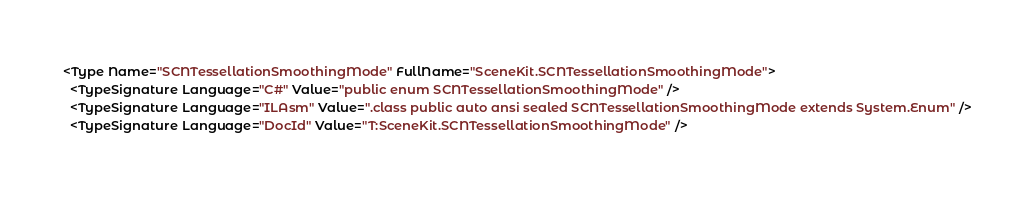<code> <loc_0><loc_0><loc_500><loc_500><_XML_><Type Name="SCNTessellationSmoothingMode" FullName="SceneKit.SCNTessellationSmoothingMode">
  <TypeSignature Language="C#" Value="public enum SCNTessellationSmoothingMode" />
  <TypeSignature Language="ILAsm" Value=".class public auto ansi sealed SCNTessellationSmoothingMode extends System.Enum" />
  <TypeSignature Language="DocId" Value="T:SceneKit.SCNTessellationSmoothingMode" /></code> 